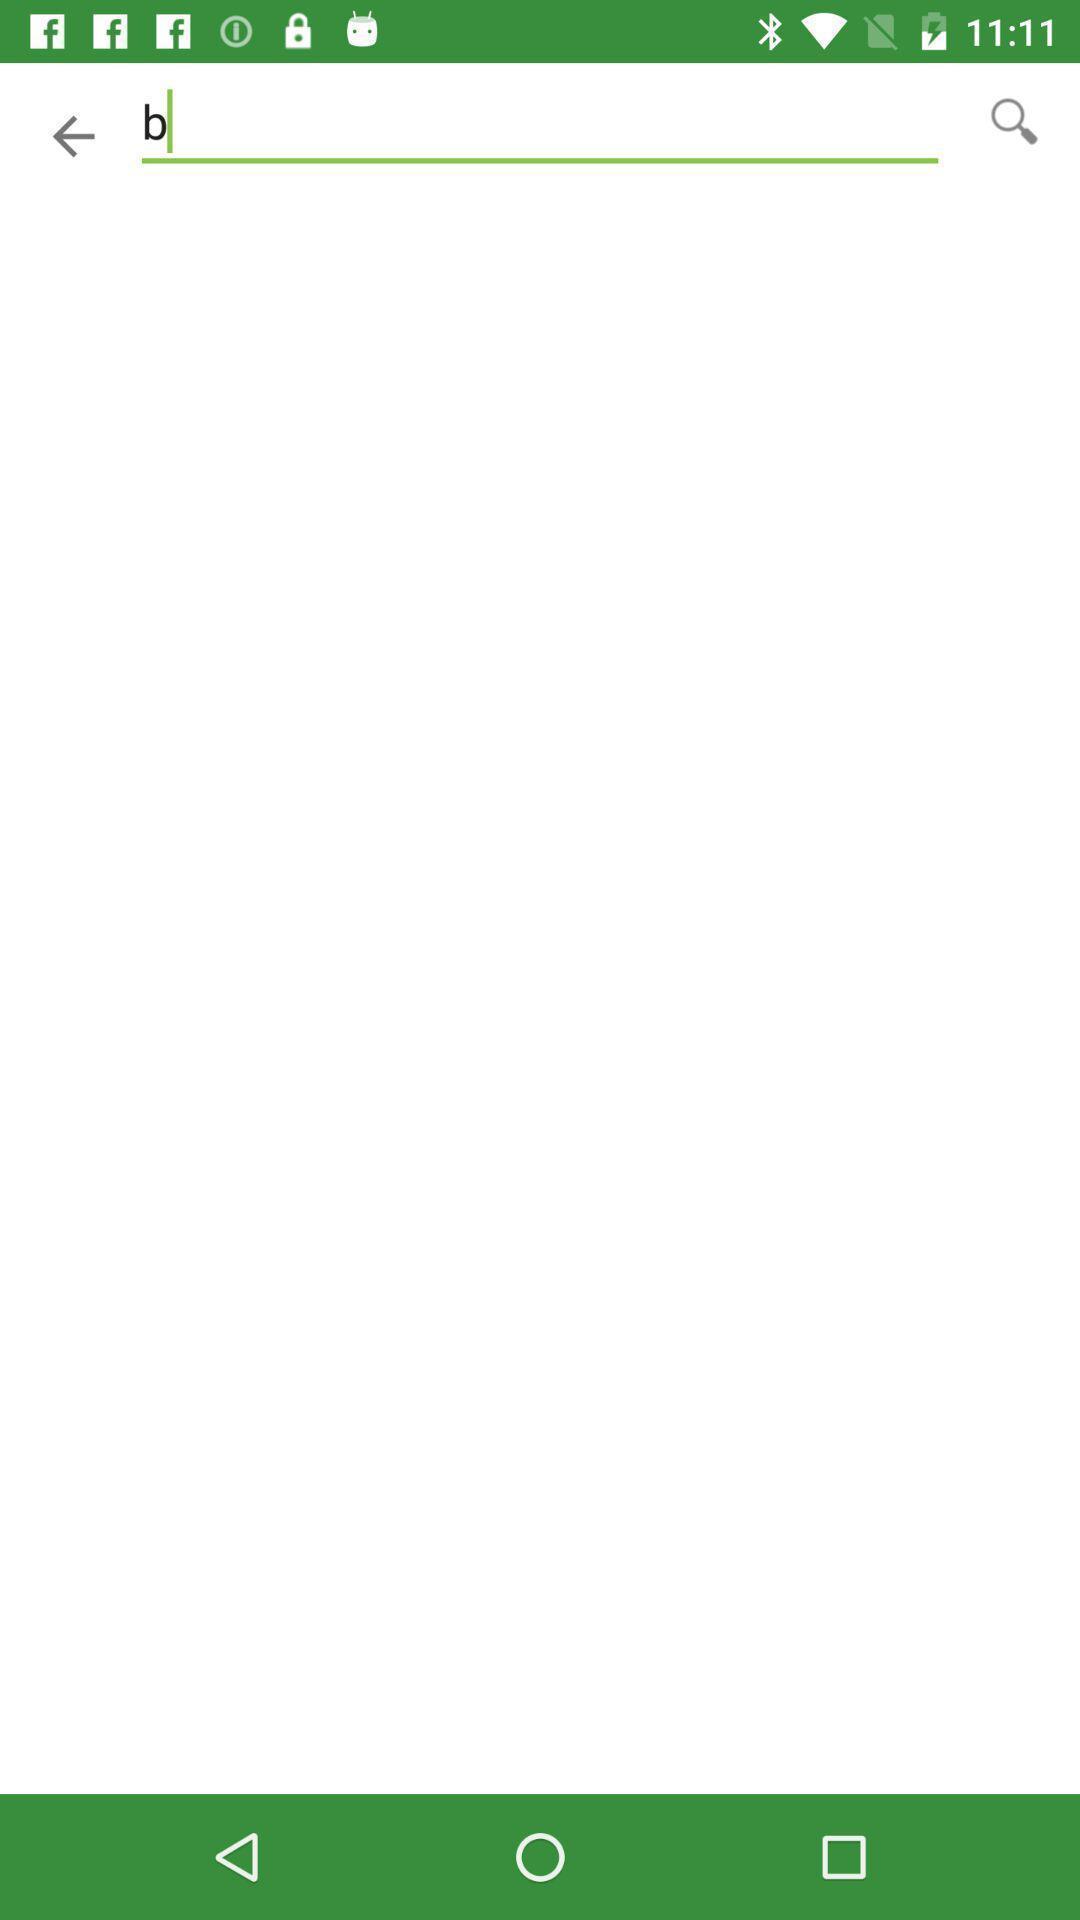Provide a description of this screenshot. Screen page shows a search option. 